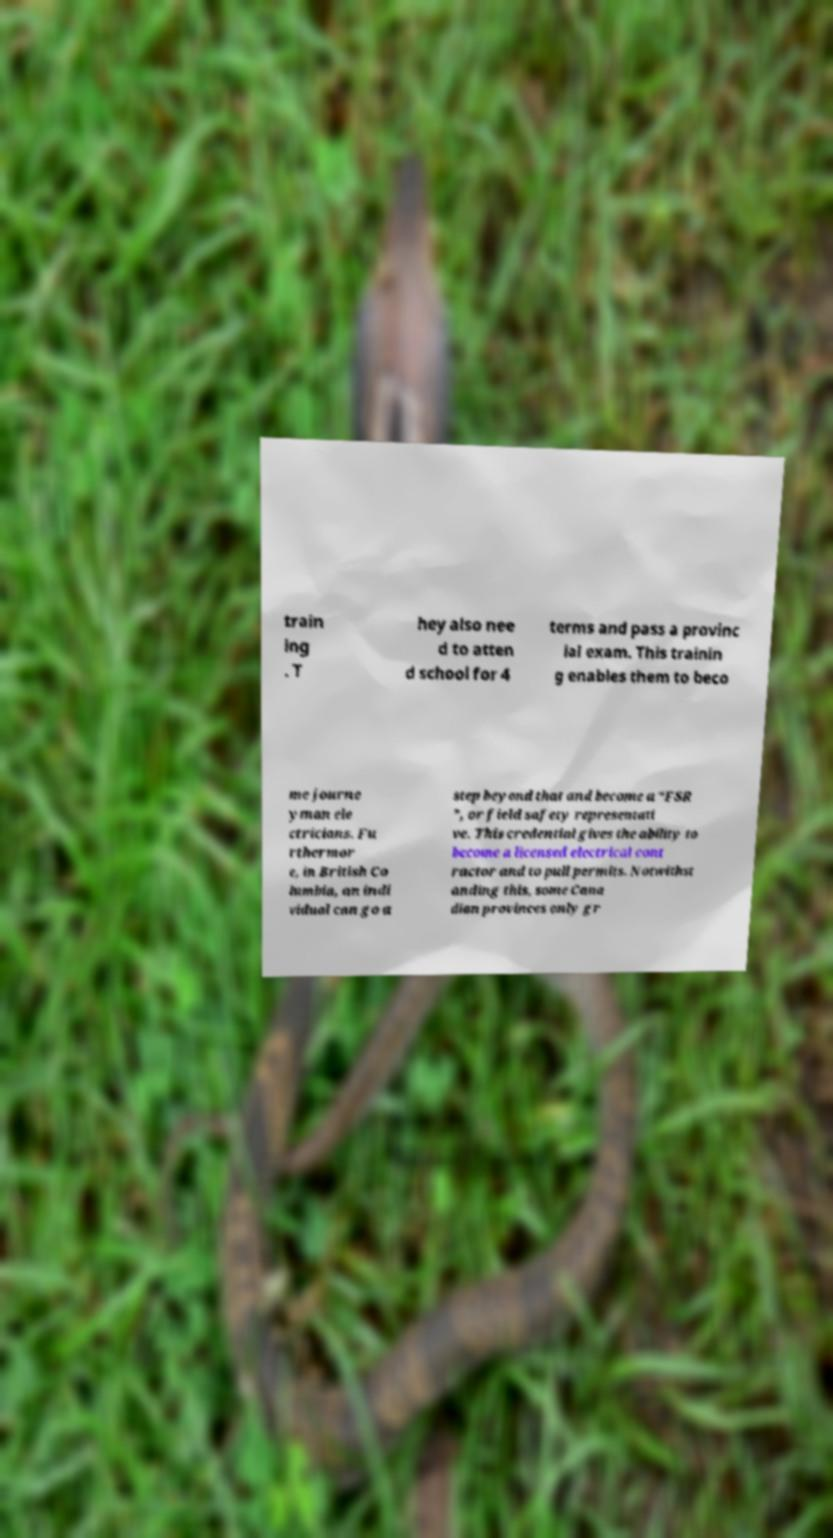Could you assist in decoding the text presented in this image and type it out clearly? train ing . T hey also nee d to atten d school for 4 terms and pass a provinc ial exam. This trainin g enables them to beco me journe yman ele ctricians. Fu rthermor e, in British Co lumbia, an indi vidual can go a step beyond that and become a “FSR ”, or field safety representati ve. This credential gives the ability to become a licensed electrical cont ractor and to pull permits. Notwithst anding this, some Cana dian provinces only gr 